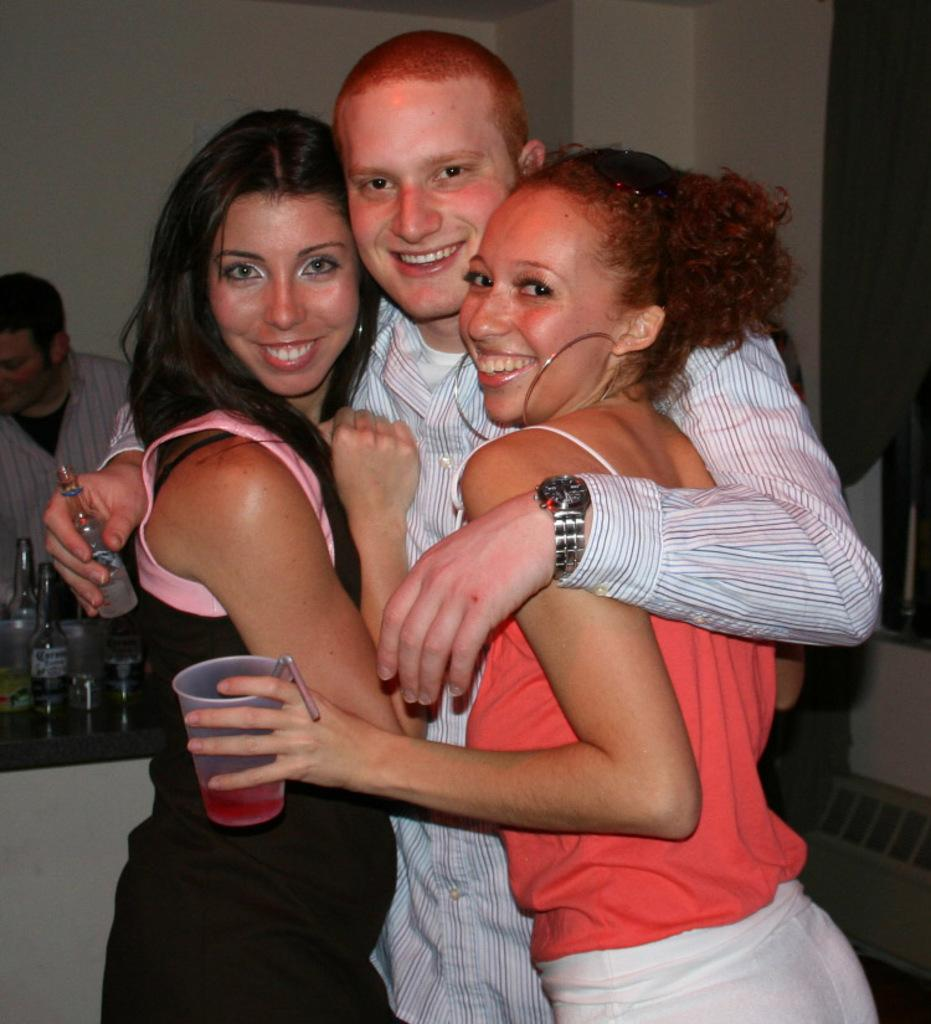How many people are in the image? There are four persons in the image. What are two of the persons doing in the image? Two of the persons are holding objects. What is present on the table in the image? There are bottles on the table. What can be seen in the background of the image? There is a wall visible in the background of the image. What type of club can be seen in the image? There is no club present in the image. How many hydrants are visible in the image? There are no hydrants visible in the image. 